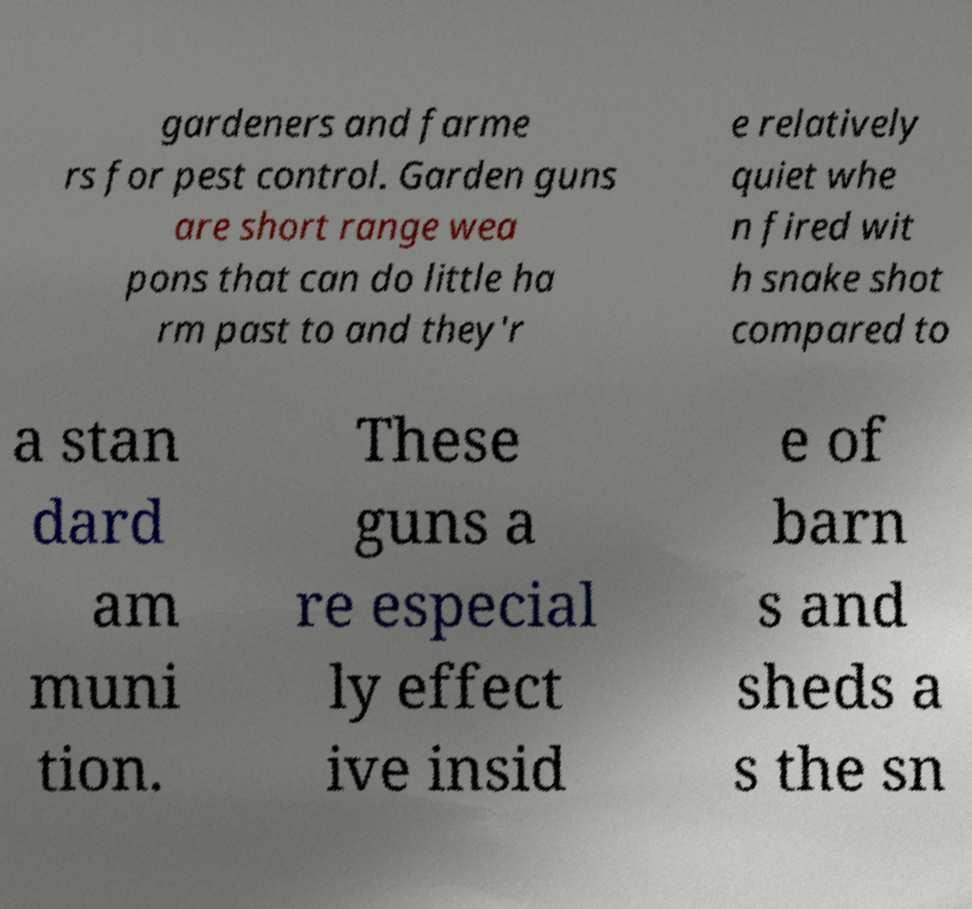Could you extract and type out the text from this image? gardeners and farme rs for pest control. Garden guns are short range wea pons that can do little ha rm past to and they'r e relatively quiet whe n fired wit h snake shot compared to a stan dard am muni tion. These guns a re especial ly effect ive insid e of barn s and sheds a s the sn 